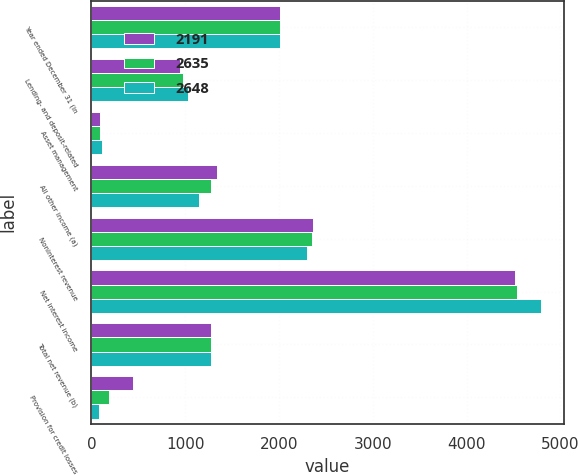Convert chart to OTSL. <chart><loc_0><loc_0><loc_500><loc_500><stacked_bar_chart><ecel><fcel>Year ended December 31 (in<fcel>Lending- and deposit-related<fcel>Asset management<fcel>All other income (a)<fcel>Noninterest revenue<fcel>Net interest income<fcel>Total net revenue (b)<fcel>Provision for credit losses<nl><fcel>2191<fcel>2015<fcel>944<fcel>88<fcel>1333<fcel>2365<fcel>4520<fcel>1279<fcel>442<nl><fcel>2635<fcel>2014<fcel>978<fcel>92<fcel>1279<fcel>2349<fcel>4533<fcel>1279<fcel>189<nl><fcel>2648<fcel>2013<fcel>1033<fcel>116<fcel>1149<fcel>2298<fcel>4794<fcel>1279<fcel>85<nl></chart> 